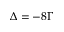<formula> <loc_0><loc_0><loc_500><loc_500>\Delta = - 8 \Gamma</formula> 